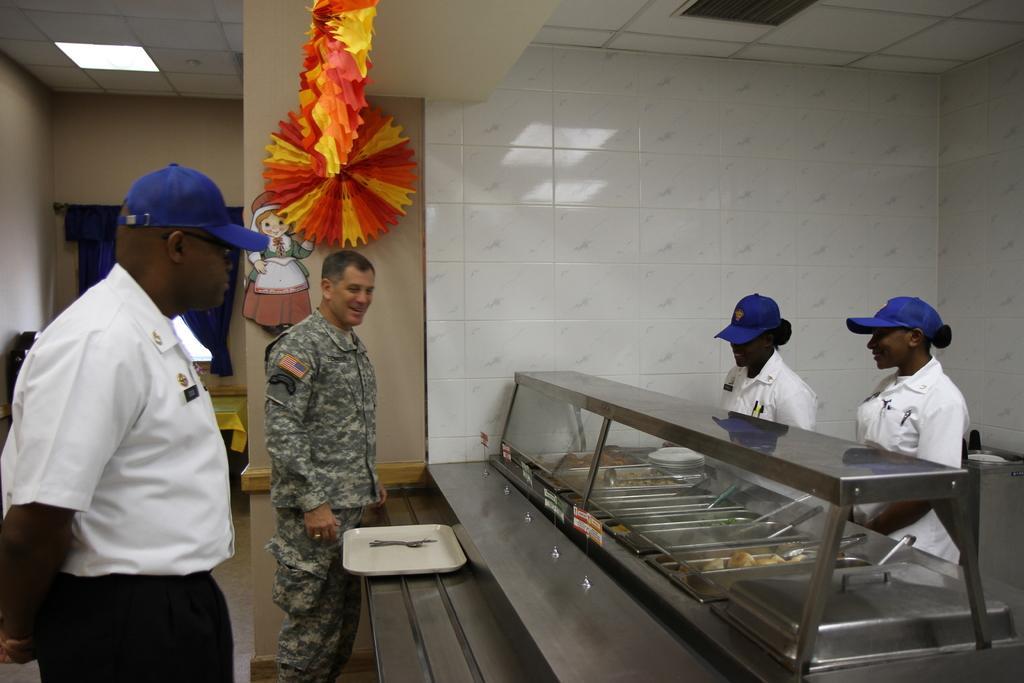In one or two sentences, can you explain what this image depicts? In this image, we can see people and some are wearing uniforms and some are wearing caps and we can see a stand with trays containing food items and there are spoons and we can see streamers and there is a poster on the wall and there is a curtain. At the top, there is a light. 